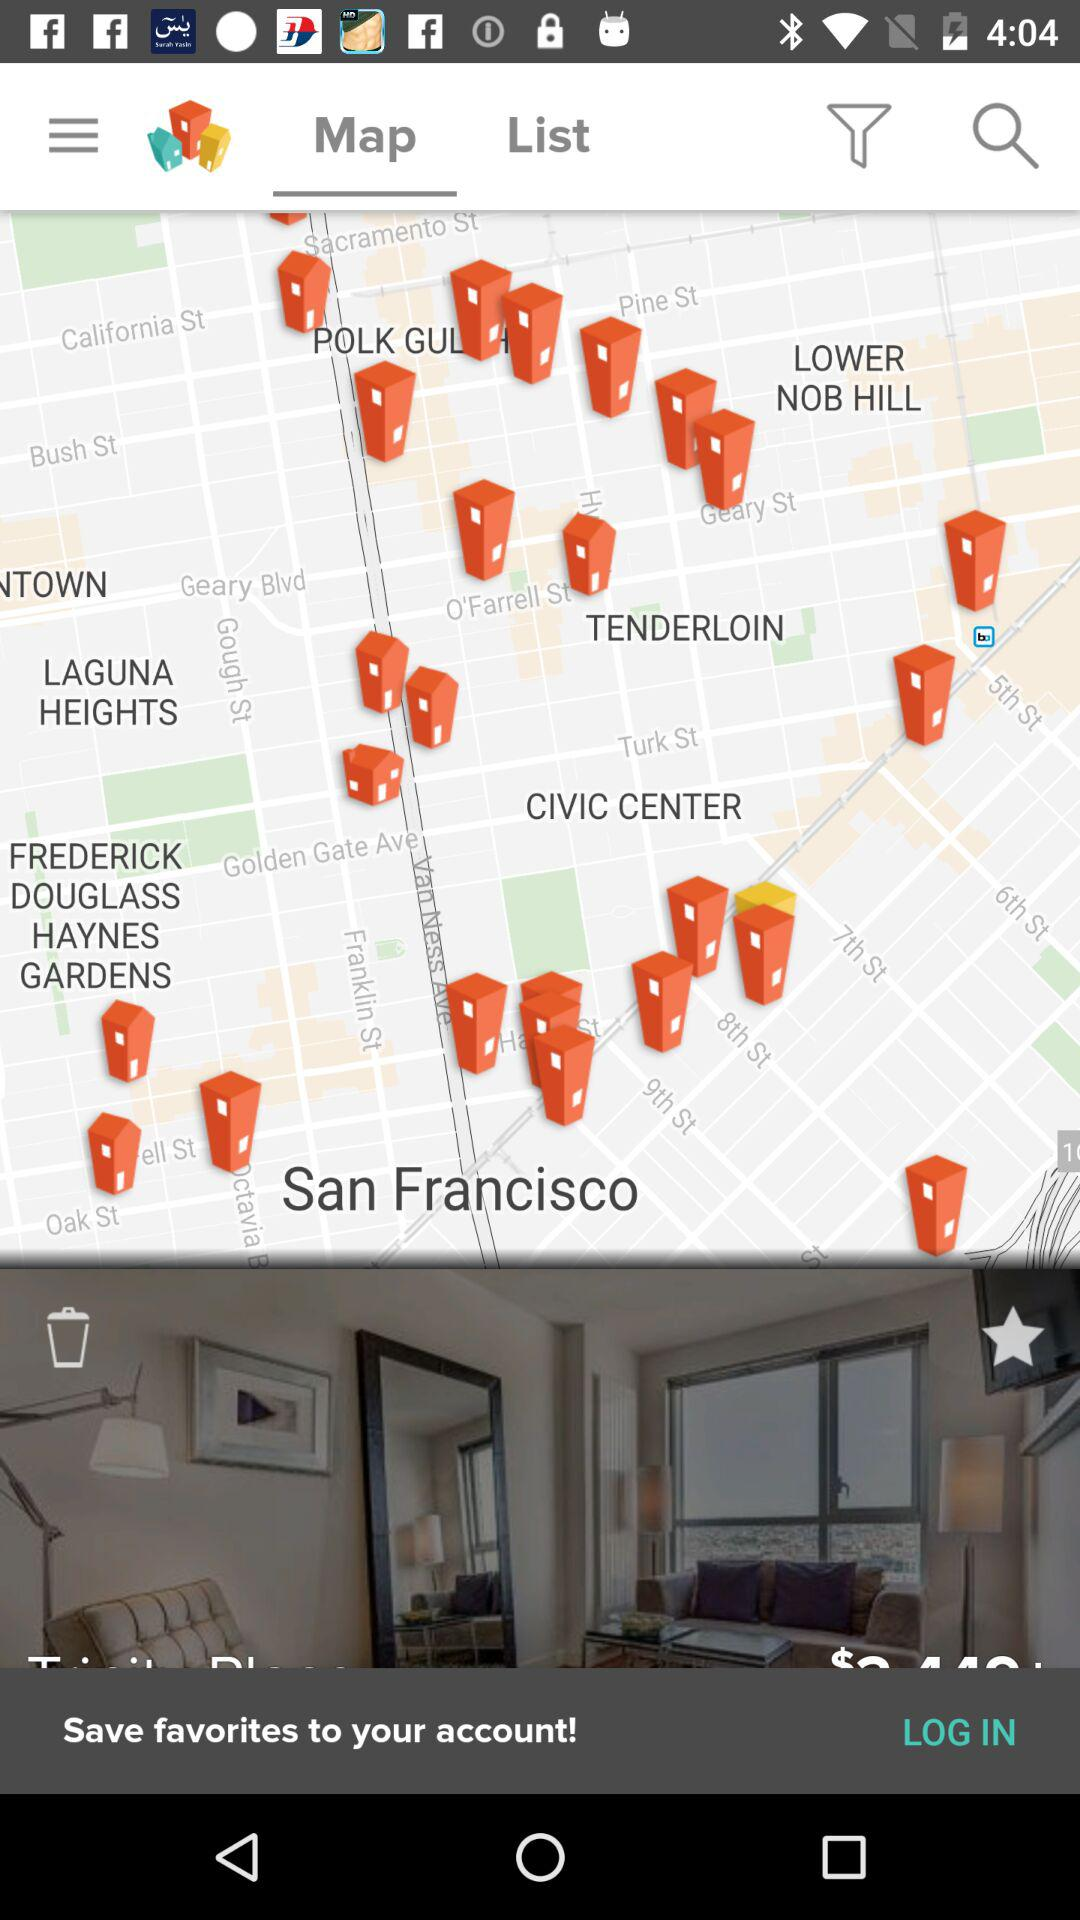Which tab is currently selected? The currently selected tab is "Map". 